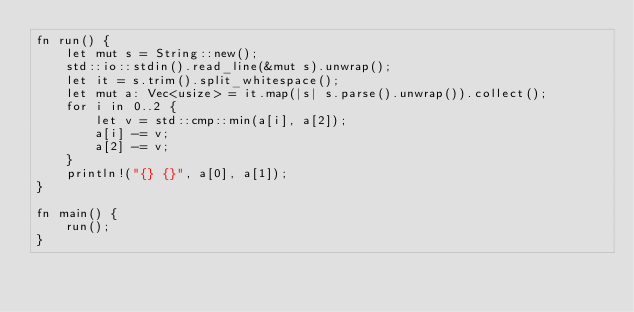<code> <loc_0><loc_0><loc_500><loc_500><_Rust_>fn run() {
    let mut s = String::new();
    std::io::stdin().read_line(&mut s).unwrap();
    let it = s.trim().split_whitespace();
    let mut a: Vec<usize> = it.map(|s| s.parse().unwrap()).collect();
    for i in 0..2 {
        let v = std::cmp::min(a[i], a[2]);
        a[i] -= v;
        a[2] -= v;
    }
    println!("{} {}", a[0], a[1]);
}

fn main() {
    run();
}</code> 